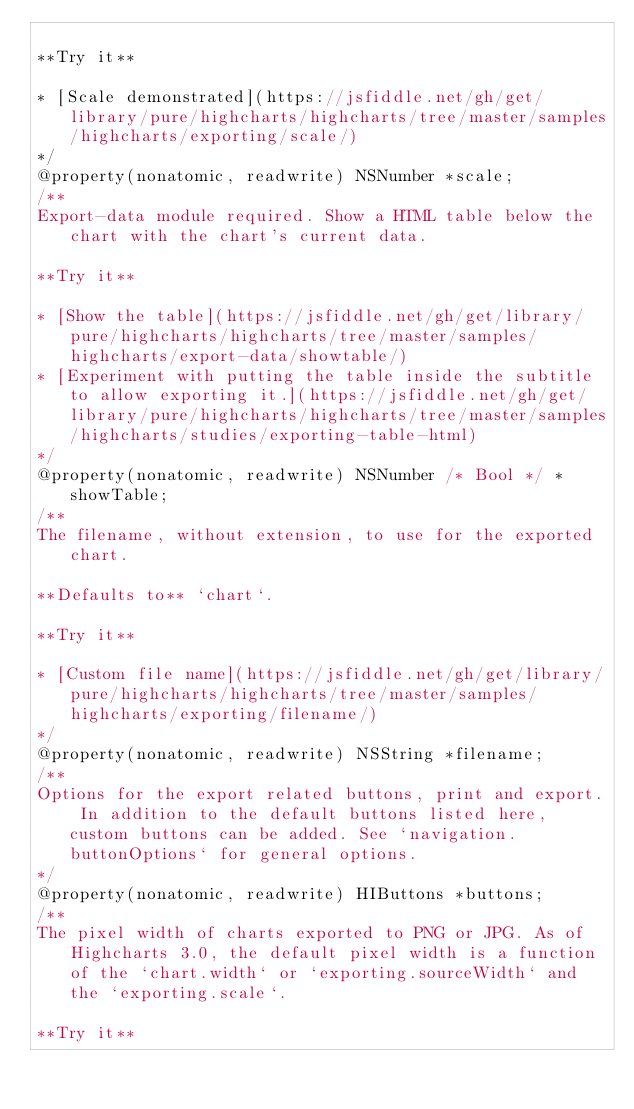Convert code to text. <code><loc_0><loc_0><loc_500><loc_500><_C_>
**Try it**

* [Scale demonstrated](https://jsfiddle.net/gh/get/library/pure/highcharts/highcharts/tree/master/samples/highcharts/exporting/scale/)
*/
@property(nonatomic, readwrite) NSNumber *scale;
/**
Export-data module required. Show a HTML table below the chart with the chart's current data.

**Try it**

* [Show the table](https://jsfiddle.net/gh/get/library/pure/highcharts/highcharts/tree/master/samples/highcharts/export-data/showtable/)
* [Experiment with putting the table inside the subtitle to allow exporting it.](https://jsfiddle.net/gh/get/library/pure/highcharts/highcharts/tree/master/samples/highcharts/studies/exporting-table-html)
*/
@property(nonatomic, readwrite) NSNumber /* Bool */ *showTable;
/**
The filename, without extension, to use for the exported chart.

**Defaults to** `chart`.

**Try it**

* [Custom file name](https://jsfiddle.net/gh/get/library/pure/highcharts/highcharts/tree/master/samples/highcharts/exporting/filename/)
*/
@property(nonatomic, readwrite) NSString *filename;
/**
Options for the export related buttons, print and export. In addition to the default buttons listed here, custom buttons can be added. See `navigation.buttonOptions` for general options.
*/
@property(nonatomic, readwrite) HIButtons *buttons;
/**
The pixel width of charts exported to PNG or JPG. As of Highcharts 3.0, the default pixel width is a function of the `chart.width` or `exporting.sourceWidth` and the `exporting.scale`.

**Try it**
</code> 